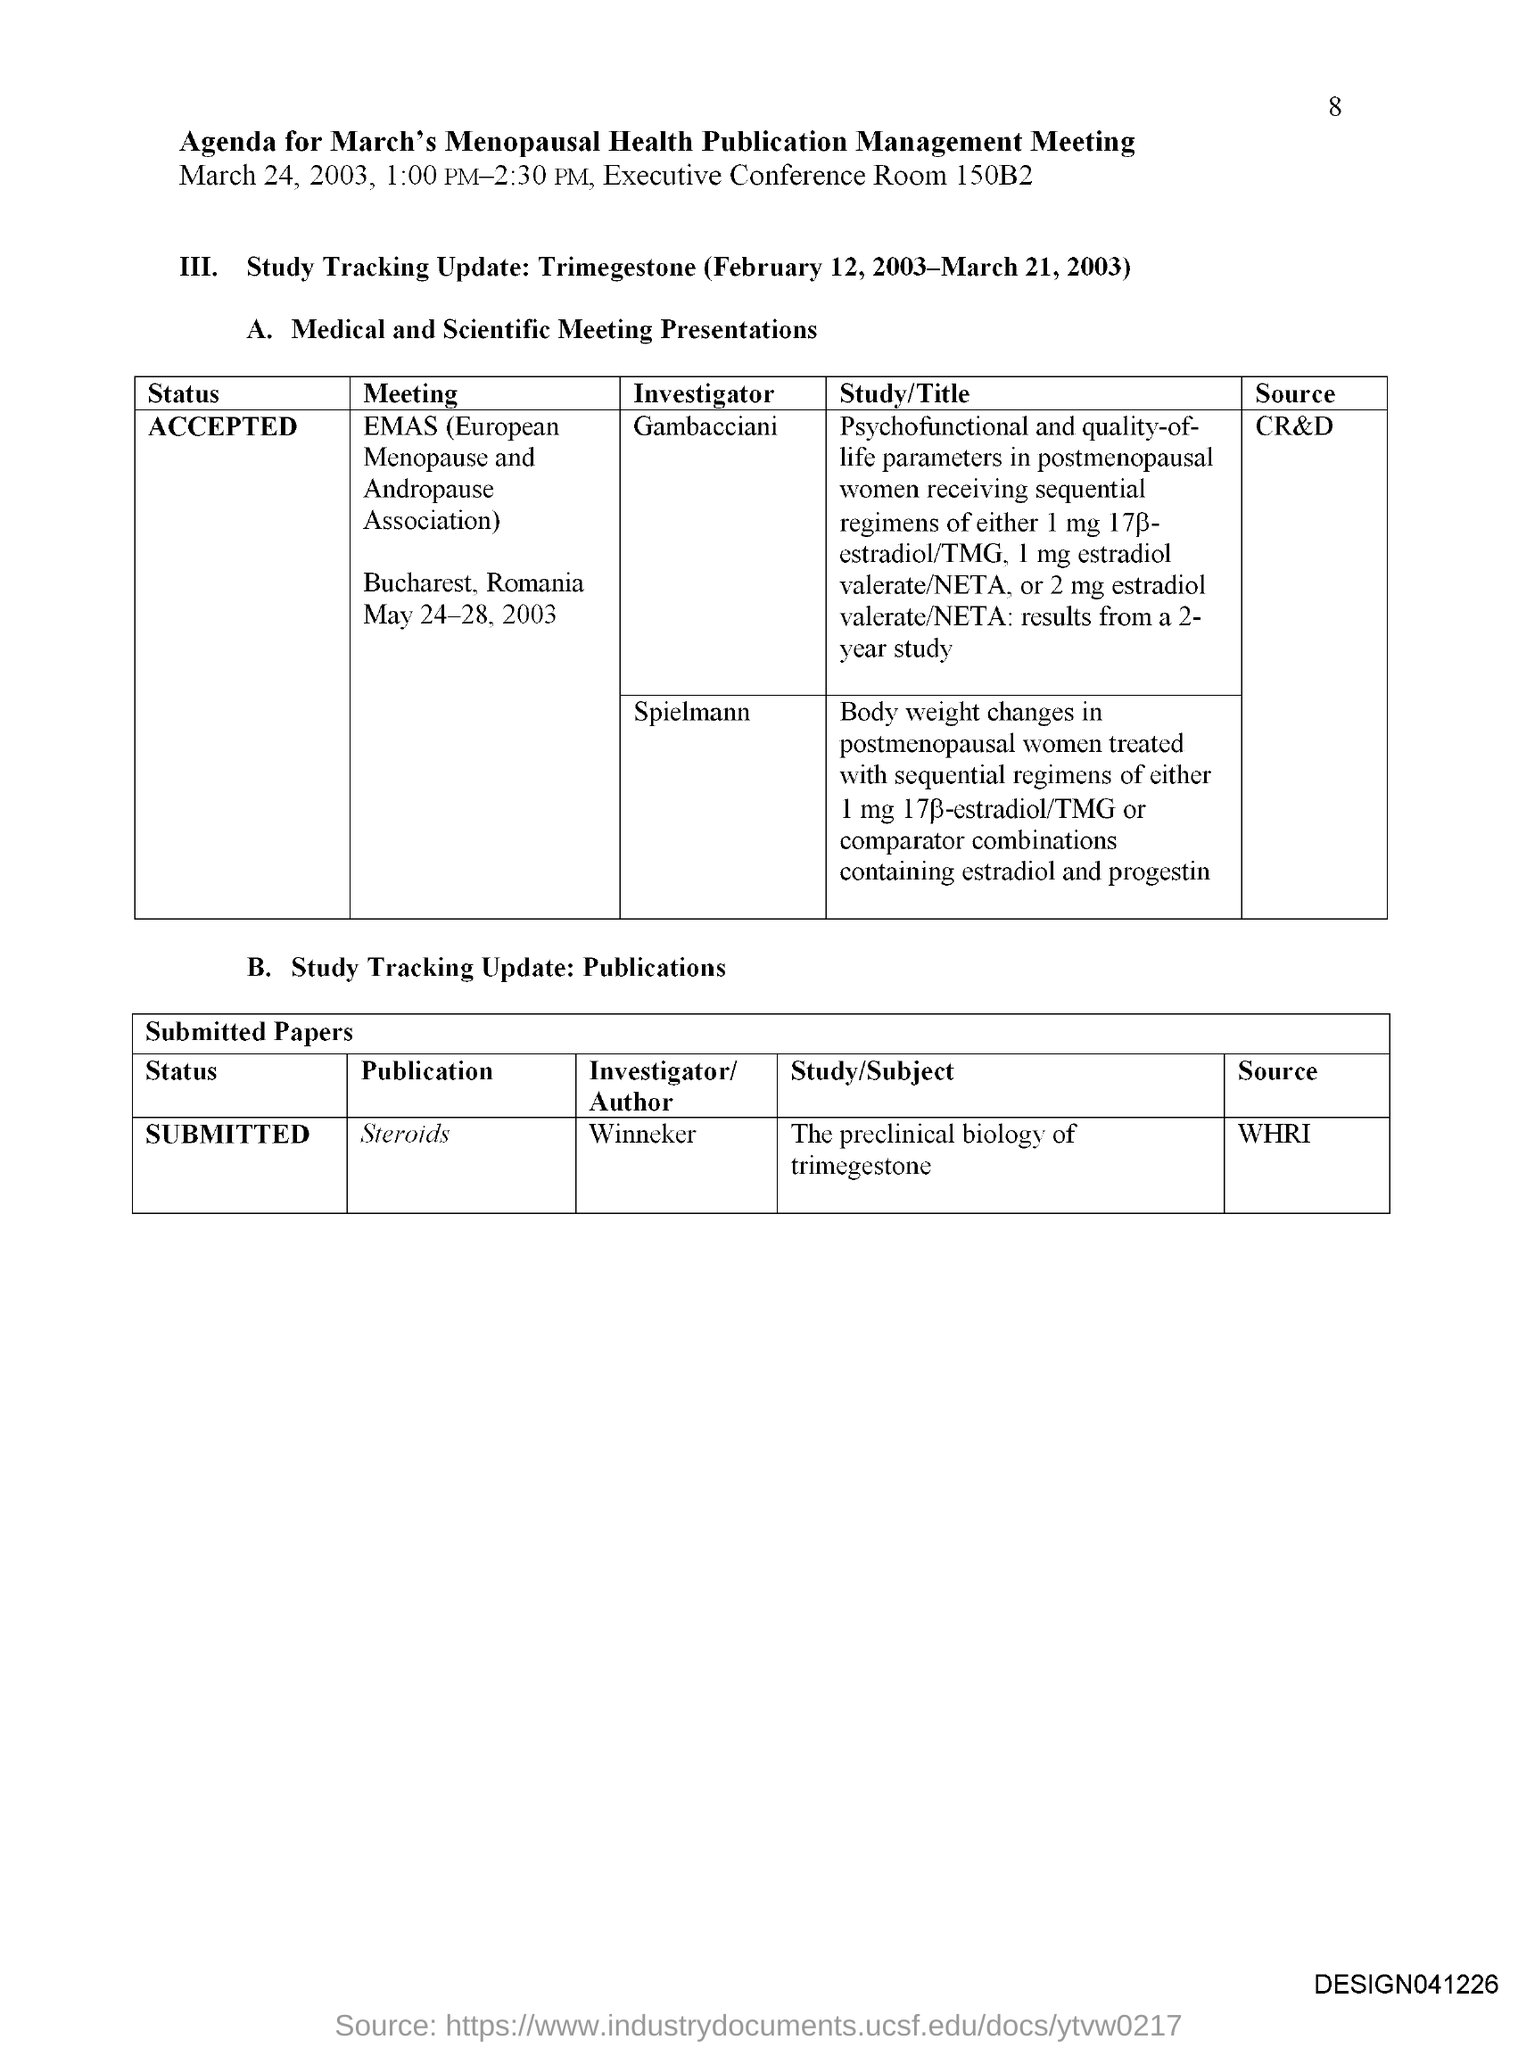Give some essential details in this illustration. The page number is 8. The source of the MEETING 'EMAS' is identified as 'cr&d'. The source of the publication "Steroids"" is unknown. The first title in the document is 'Agenda for March's Menopausal Health Publication Management Meeting.' The room number is 150B2. 